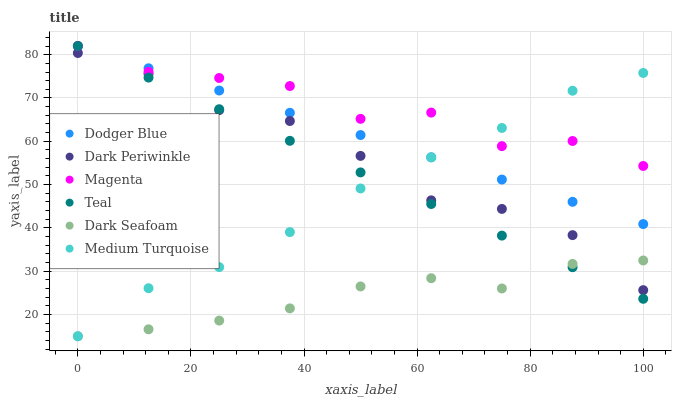Does Dark Seafoam have the minimum area under the curve?
Answer yes or no. Yes. Does Magenta have the maximum area under the curve?
Answer yes or no. Yes. Does Dodger Blue have the minimum area under the curve?
Answer yes or no. No. Does Dodger Blue have the maximum area under the curve?
Answer yes or no. No. Is Dodger Blue the smoothest?
Answer yes or no. Yes. Is Magenta the roughest?
Answer yes or no. Yes. Is Dark Seafoam the smoothest?
Answer yes or no. No. Is Dark Seafoam the roughest?
Answer yes or no. No. Does Medium Turquoise have the lowest value?
Answer yes or no. Yes. Does Dodger Blue have the lowest value?
Answer yes or no. No. Does Magenta have the highest value?
Answer yes or no. Yes. Does Dark Seafoam have the highest value?
Answer yes or no. No. Is Dark Periwinkle less than Dodger Blue?
Answer yes or no. Yes. Is Magenta greater than Dark Seafoam?
Answer yes or no. Yes. Does Teal intersect Dark Periwinkle?
Answer yes or no. Yes. Is Teal less than Dark Periwinkle?
Answer yes or no. No. Is Teal greater than Dark Periwinkle?
Answer yes or no. No. Does Dark Periwinkle intersect Dodger Blue?
Answer yes or no. No. 